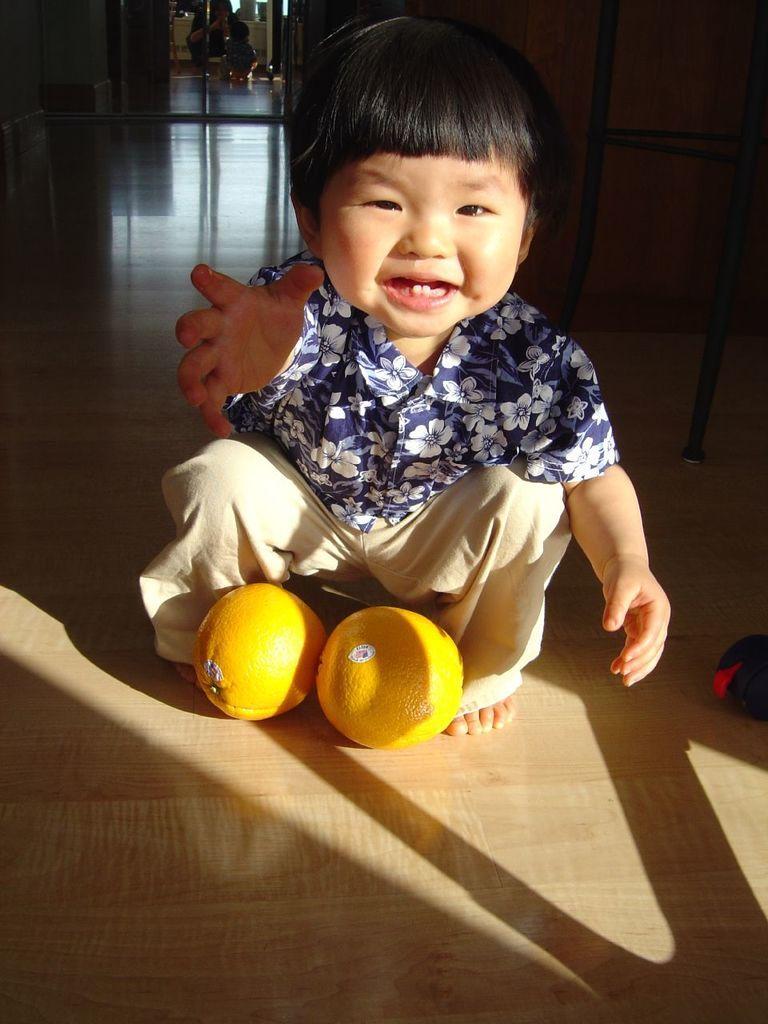In one or two sentences, can you explain what this image depicts? In this image there is a boy. In front of him there are two oranges. On the right side of the image there are some objects. At the bottom of the image there is a floor. In the background of the image there is a glass door through which we can see a person holding the mobile. In front of him there is a boy. 